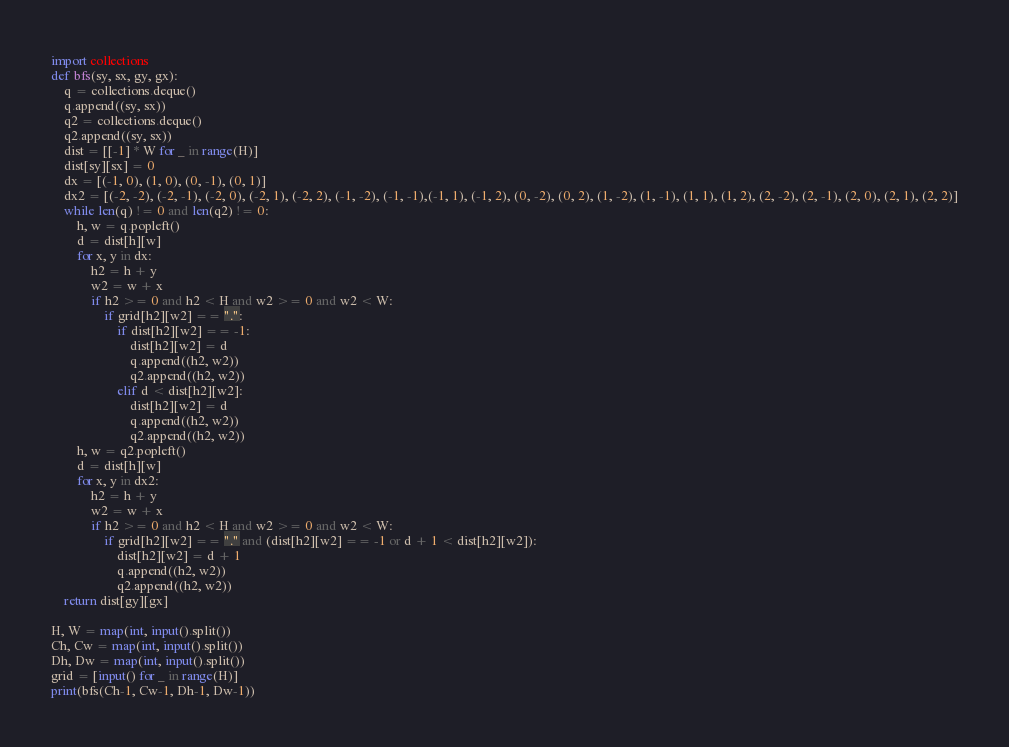<code> <loc_0><loc_0><loc_500><loc_500><_Python_>import collections
def bfs(sy, sx, gy, gx):
    q = collections.deque()
    q.append((sy, sx))
    q2 = collections.deque()
    q2.append((sy, sx))
    dist = [[-1] * W for _ in range(H)]
    dist[sy][sx] = 0
    dx = [(-1, 0), (1, 0), (0, -1), (0, 1)]
    dx2 = [(-2, -2), (-2, -1), (-2, 0), (-2, 1), (-2, 2), (-1, -2), (-1, -1),(-1, 1), (-1, 2), (0, -2), (0, 2), (1, -2), (1, -1), (1, 1), (1, 2), (2, -2), (2, -1), (2, 0), (2, 1), (2, 2)]
    while len(q) != 0 and len(q2) != 0:
        h, w = q.popleft()
        d = dist[h][w]
        for x, y in dx:
            h2 = h + y
            w2 = w + x
            if h2 >= 0 and h2 < H and w2 >= 0 and w2 < W:
                if grid[h2][w2] == ".":
                    if dist[h2][w2] == -1:
                        dist[h2][w2] = d
                        q.append((h2, w2))
                        q2.append((h2, w2))
                    elif d < dist[h2][w2]:
                        dist[h2][w2] = d
                        q.append((h2, w2))
                        q2.append((h2, w2))
        h, w = q2.popleft()
        d = dist[h][w]
        for x, y in dx2:
            h2 = h + y
            w2 = w + x
            if h2 >= 0 and h2 < H and w2 >= 0 and w2 < W:
                if grid[h2][w2] == "." and (dist[h2][w2] == -1 or d + 1 < dist[h2][w2]):
                    dist[h2][w2] = d + 1
                    q.append((h2, w2))
                    q2.append((h2, w2))
    return dist[gy][gx]

H, W = map(int, input().split())
Ch, Cw = map(int, input().split())
Dh, Dw = map(int, input().split())
grid = [input() for _ in range(H)]
print(bfs(Ch-1, Cw-1, Dh-1, Dw-1))
</code> 